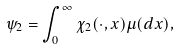<formula> <loc_0><loc_0><loc_500><loc_500>\psi _ { 2 } = \int _ { 0 } ^ { \infty } \chi _ { 2 } ( { \cdot } , x ) \mu ( d x ) ,</formula> 